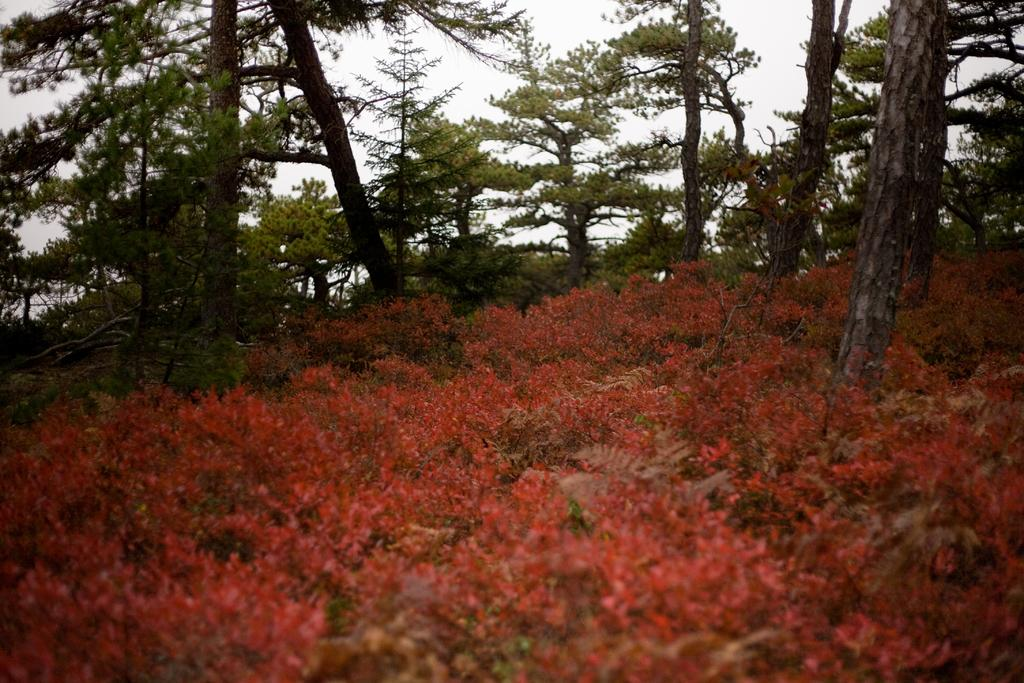What type of living organisms can be seen in the image? Plants can be seen in the image. What can be seen in the background of the image? There are trees in the background of the image. What type of cough medicine is visible in the image? There is no cough medicine present in the image; it features plants and trees. How many toes can be seen in the image? There are no toes visible in the image, as it only contains plants and trees. 